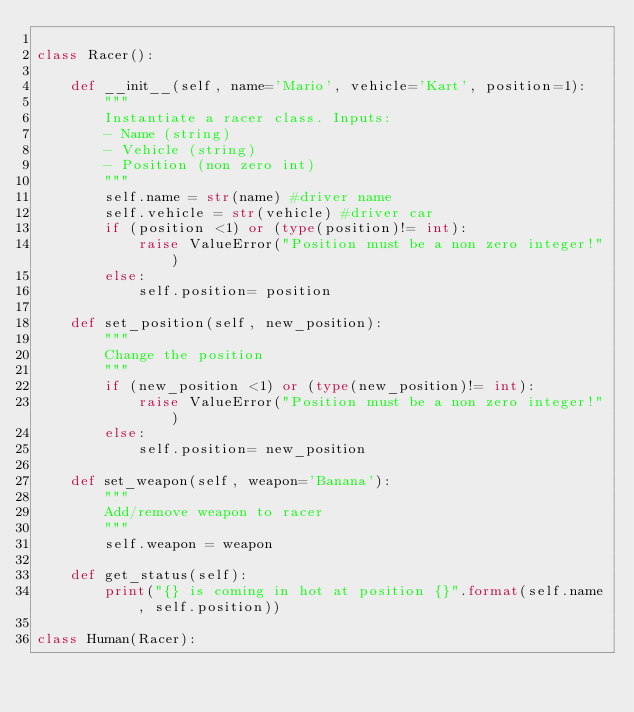<code> <loc_0><loc_0><loc_500><loc_500><_Python_>
class Racer():
    
    def __init__(self, name='Mario', vehicle='Kart', position=1):
        """
        Instantiate a racer class. Inputs:
        - Name (string)
        - Vehicle (string)
        - Position (non zero int)
        """
        self.name = str(name) #driver name
        self.vehicle = str(vehicle) #driver car
        if (position <1) or (type(position)!= int):
            raise ValueError("Position must be a non zero integer!")
        else:
            self.position= position
        
    def set_position(self, new_position):
        """
        Change the position
        """
        if (new_position <1) or (type(new_position)!= int):
            raise ValueError("Position must be a non zero integer!")
        else:
            self.position= new_position
    
    def set_weapon(self, weapon='Banana'):
        """
        Add/remove weapon to racer
        """
        self.weapon = weapon
        
    def get_status(self):
        print("{} is coming in hot at position {}".format(self.name, self.position))
        
class Human(Racer):
</code> 